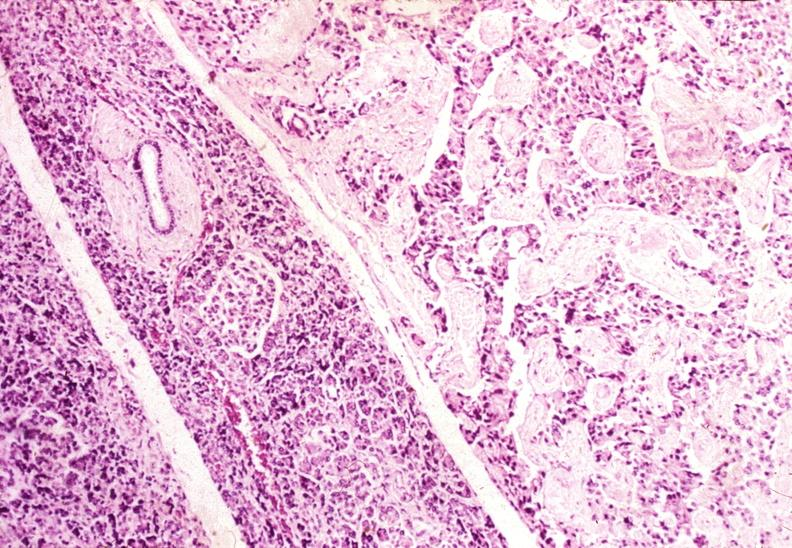where is this?
Answer the question using a single word or phrase. Pancreas 